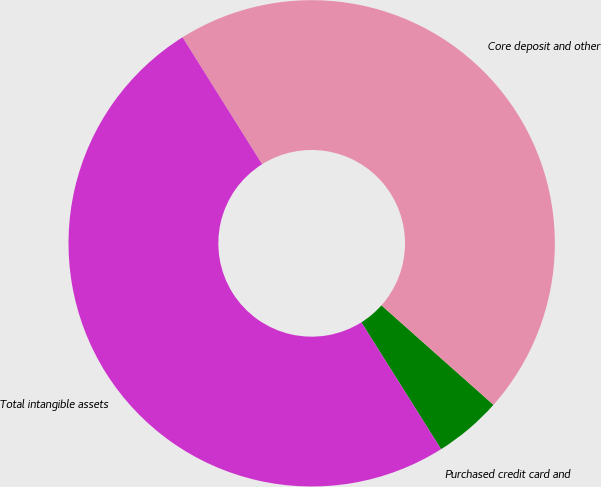<chart> <loc_0><loc_0><loc_500><loc_500><pie_chart><fcel>Purchased credit card and<fcel>Core deposit and other<fcel>Total intangible assets<nl><fcel>4.51%<fcel>45.47%<fcel>50.02%<nl></chart> 